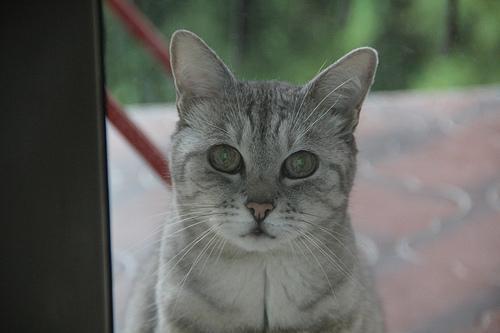How many cats looking?
Give a very brief answer. 1. 